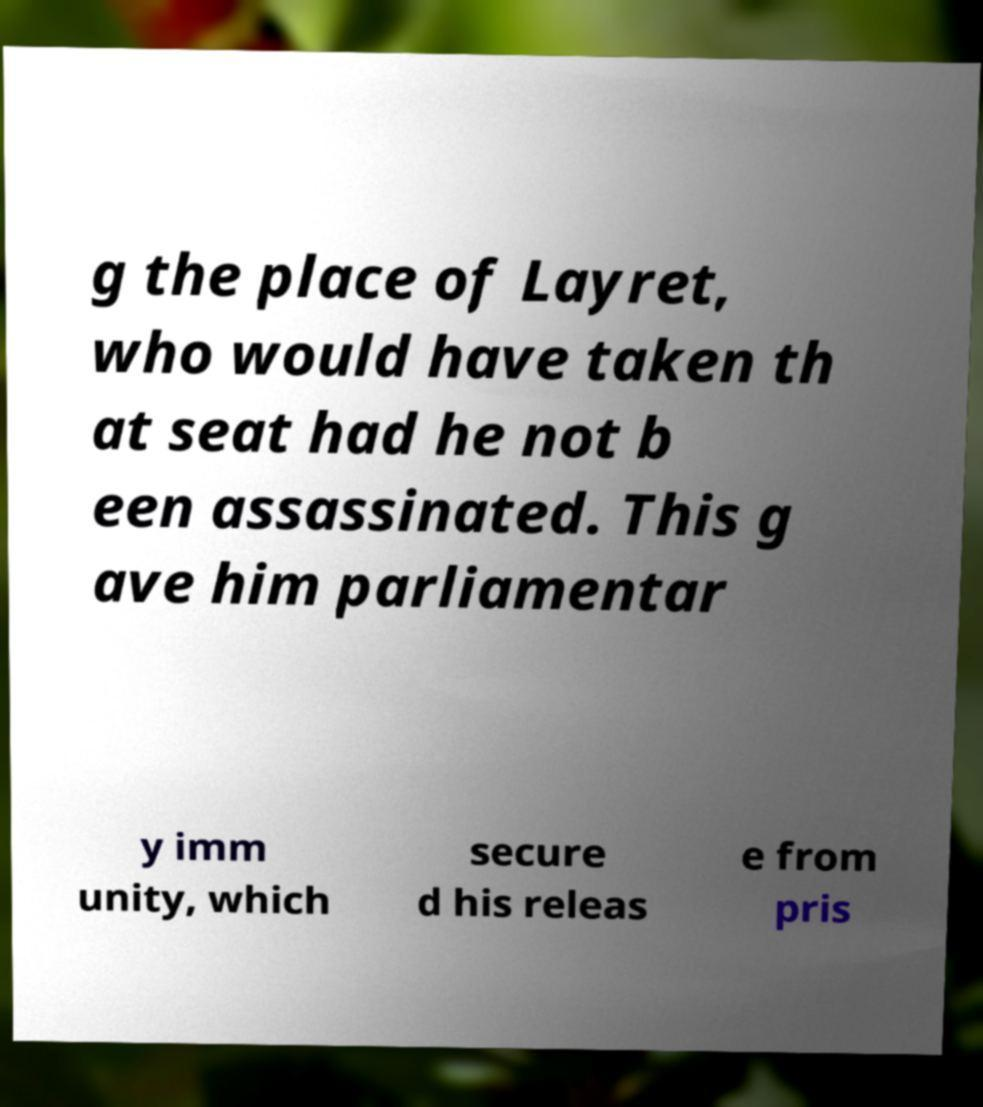Can you read and provide the text displayed in the image?This photo seems to have some interesting text. Can you extract and type it out for me? g the place of Layret, who would have taken th at seat had he not b een assassinated. This g ave him parliamentar y imm unity, which secure d his releas e from pris 